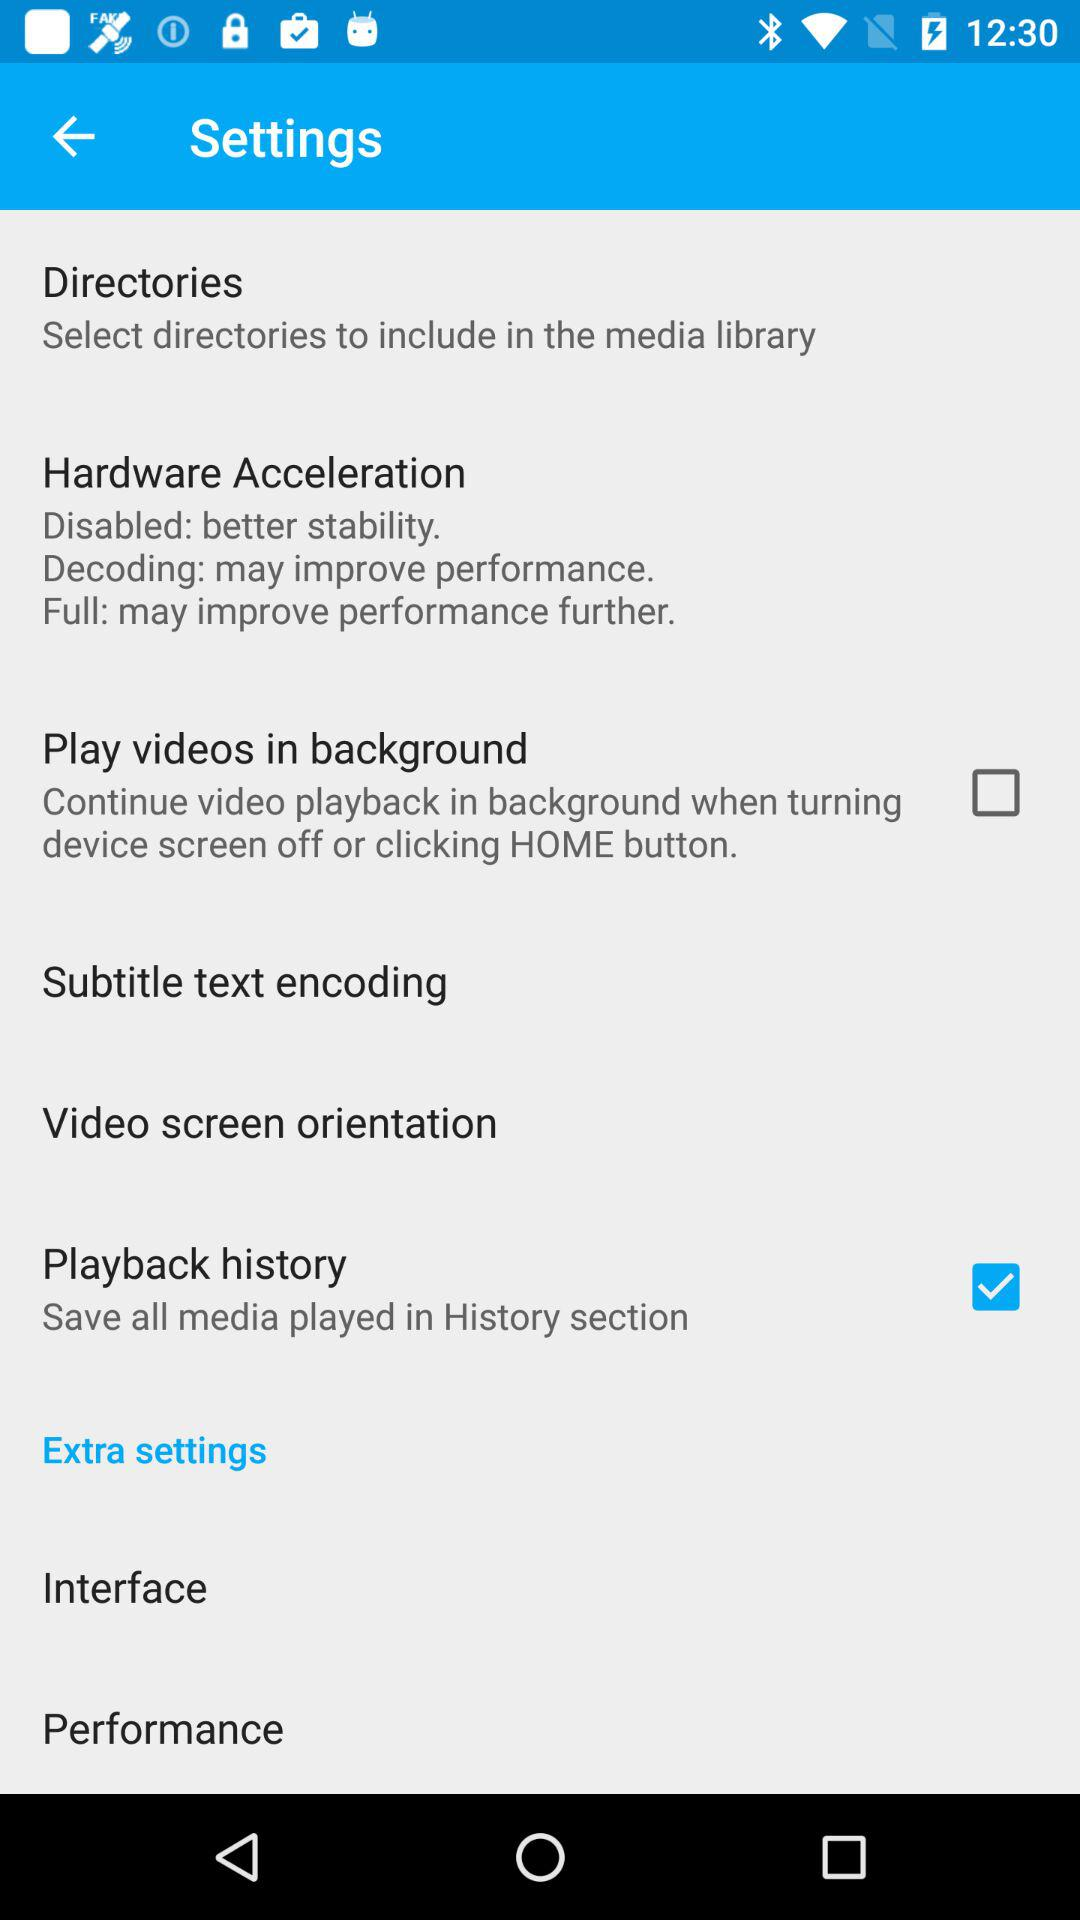What is the status of "Play videos in background"? The status of "Play videos in background" is "off". 